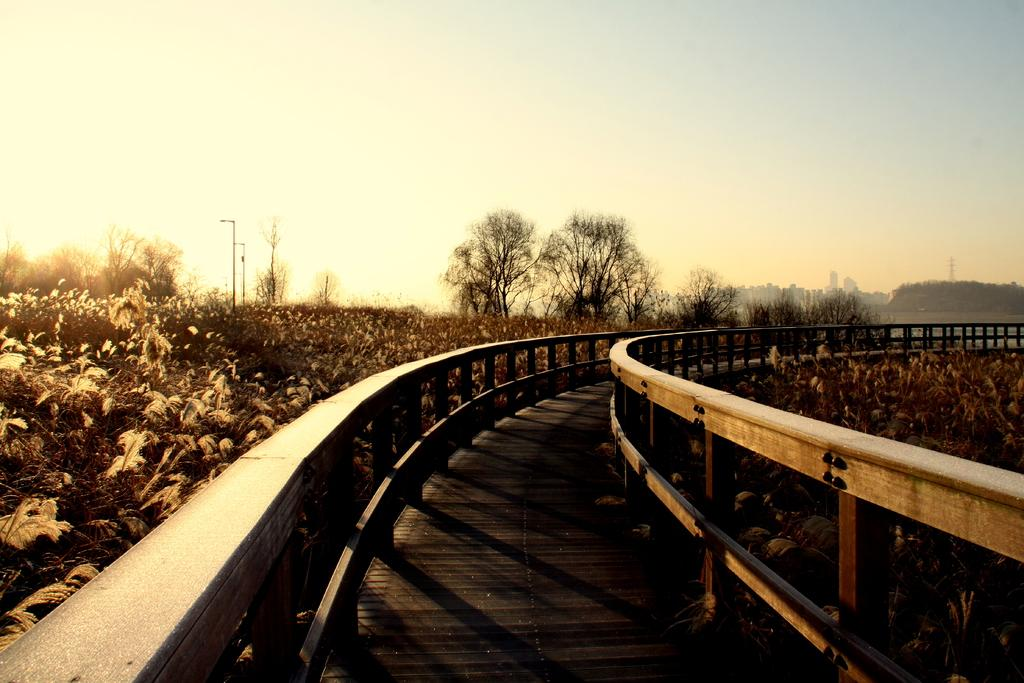What is the main feature of the image? There is a path at the center of the image. What surrounds the path? There is a wooden railing on both sides of the path. What can be seen alongside the path? Plants are present alongside the path. What is visible in the background of the image? There are trees, buildings, and the sky visible in the background of the image. What type of marble can be seen on the path in the image? There is no marble present on the path in the image; it is made of a different material. How does the hair of the trees in the background look like in the image? There are no hair-like features on the trees in the background of the image; they are simply trees with leaves and branches. 